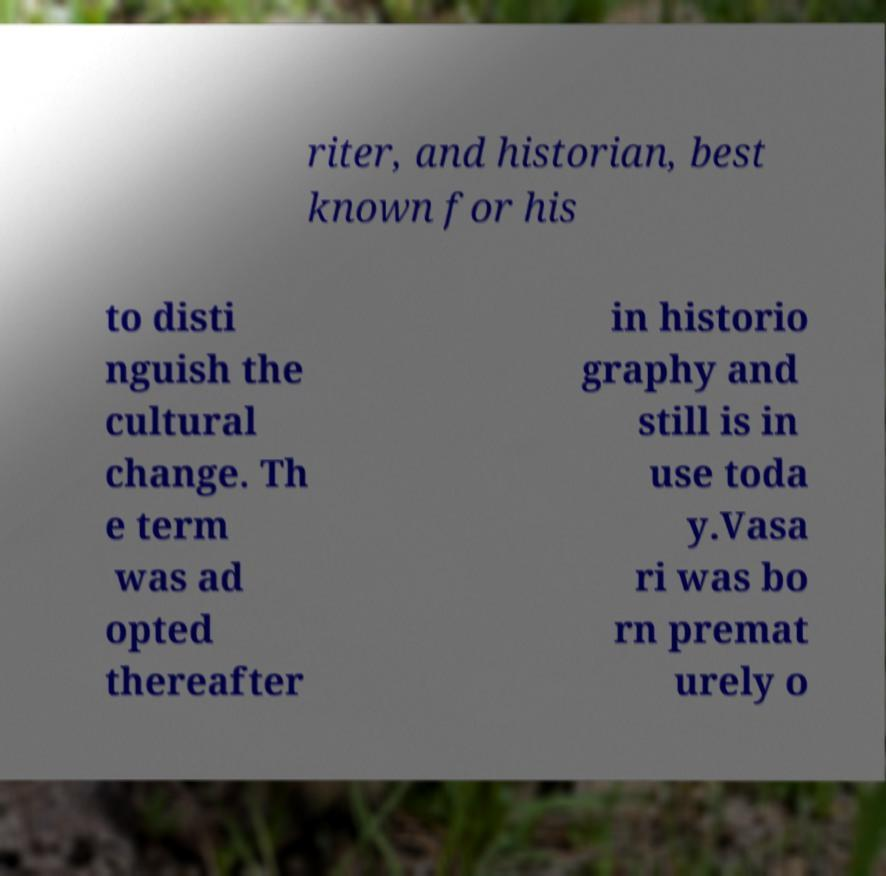Can you accurately transcribe the text from the provided image for me? riter, and historian, best known for his to disti nguish the cultural change. Th e term was ad opted thereafter in historio graphy and still is in use toda y.Vasa ri was bo rn premat urely o 